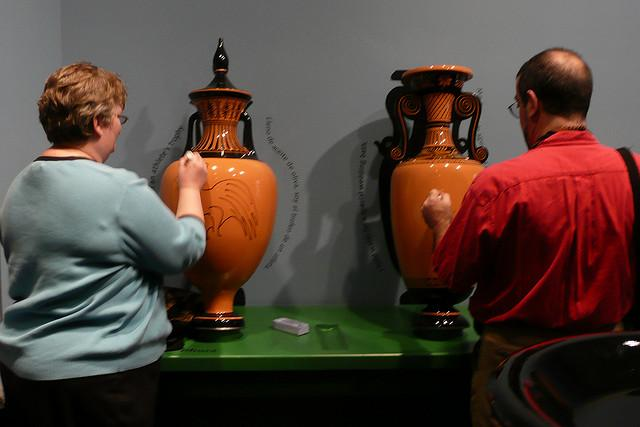What is the woman drawing? rooster 